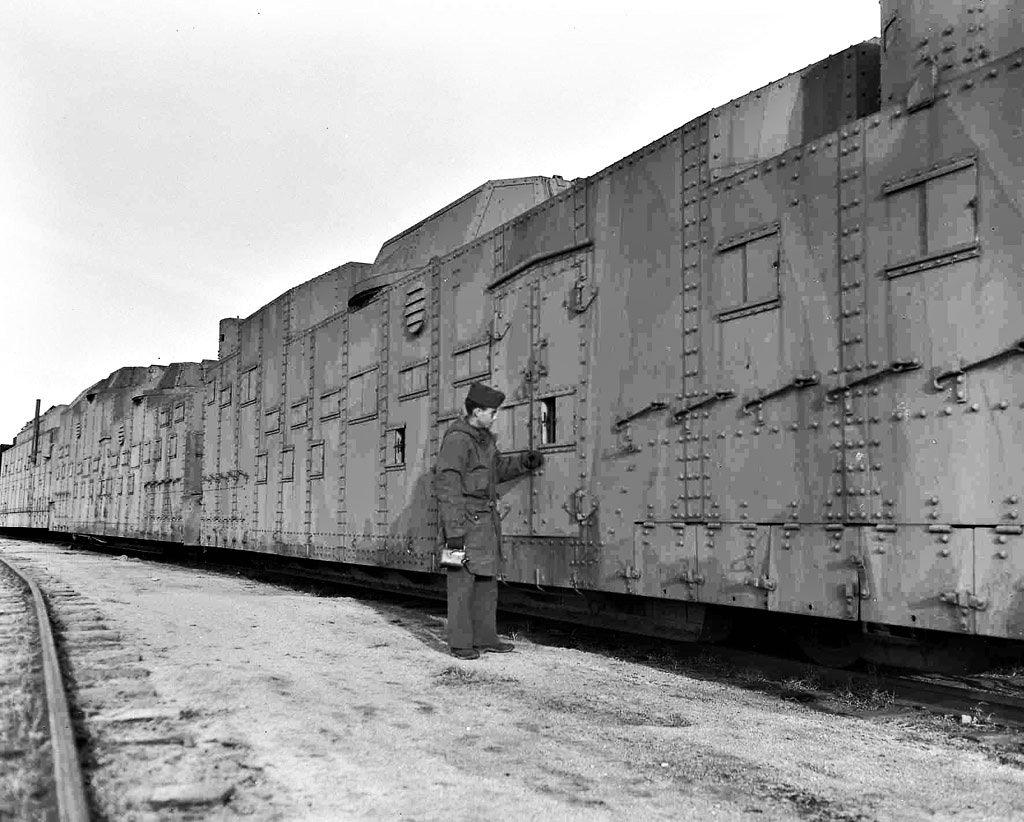What is the color scheme of the image? The image is black and white. Can you describe the person in the image? There is a person standing in the image. What is the main mode of transportation in the image? There is a train in the image. Where is the train located in the image? The train is on a railway track. What else can be seen in the image besides the train and the person? There is a pathway in the image. How many stars can be seen in the image? There are no stars visible in the image, as it is a black and white image of a person, a train, and a pathway. 